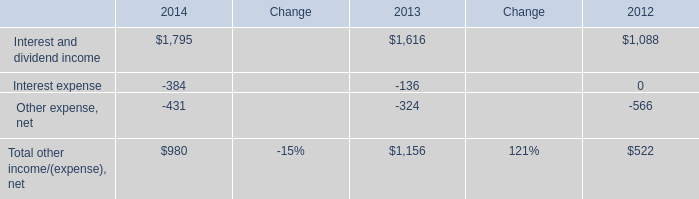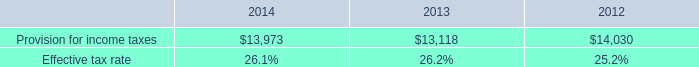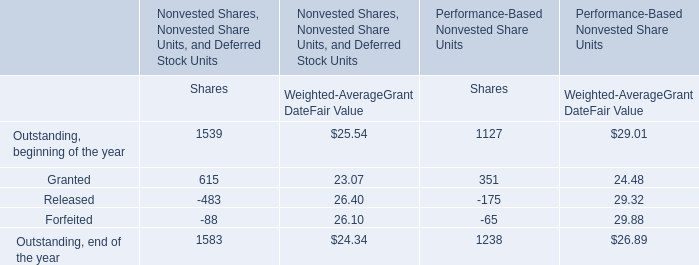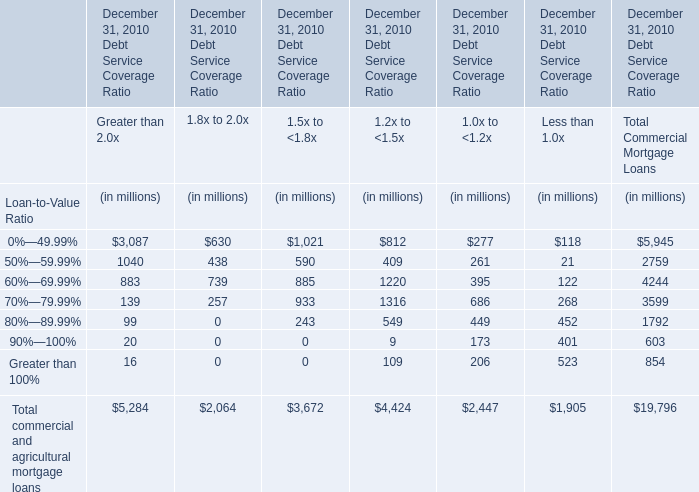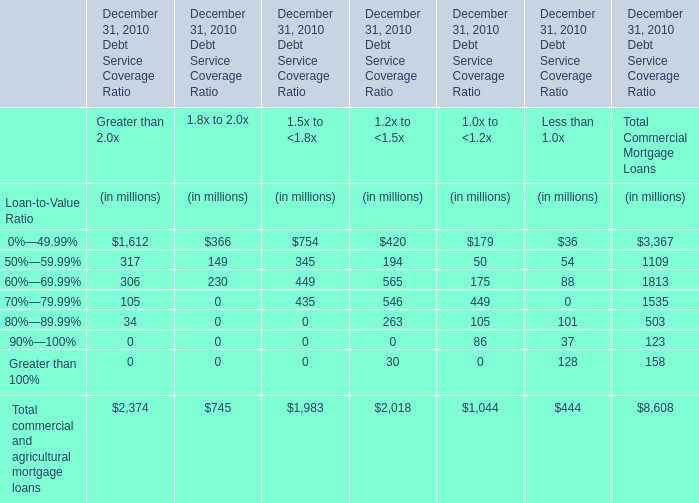What's the average of Interest and dividend income of 2014, and Provision for income taxes of 2013 ? 
Computations: ((1795.0 + 13118.0) / 2)
Answer: 7456.5. 